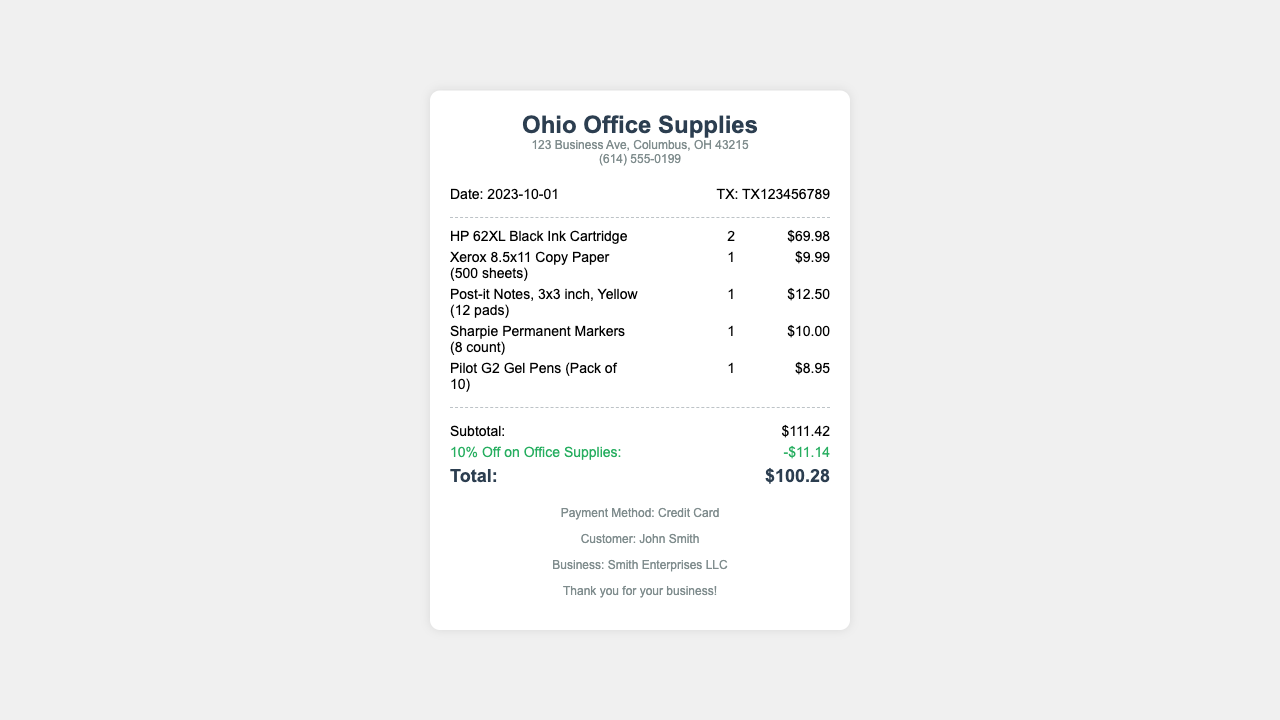What is the date of the transaction? The date of the transaction is listed in the document under the transaction info section.
Answer: 2023-10-01 What is the store name? The store name is prominently displayed at the top of the receipt.
Answer: Ohio Office Supplies How many HP 62XL Black Ink Cartridges were purchased? The quantity purchased for the HP 62XL Black Ink Cartridges is indicated next to the item description.
Answer: 2 What is the subtotal before the discount? The subtotal is shown in the totals section before any discounts are applied.
Answer: $111.42 What was the percentage of the discount applied? The discount percentage is stated in the totals section next to the discount amount.
Answer: 10% What is the total amount after the discount? The total amount is clearly indicated at the bottom of the totals section of the receipt.
Answer: $100.28 Who is the customer on the receipt? The customer's name is mentioned in the footer of the receipt.
Answer: John Smith What payment method was used? The payment method is specified in the footer section of the receipt.
Answer: Credit Card What item has the highest price? The highest priced item can be determined by comparing the individual item prices listed.
Answer: HP 62XL Black Ink Cartridge 